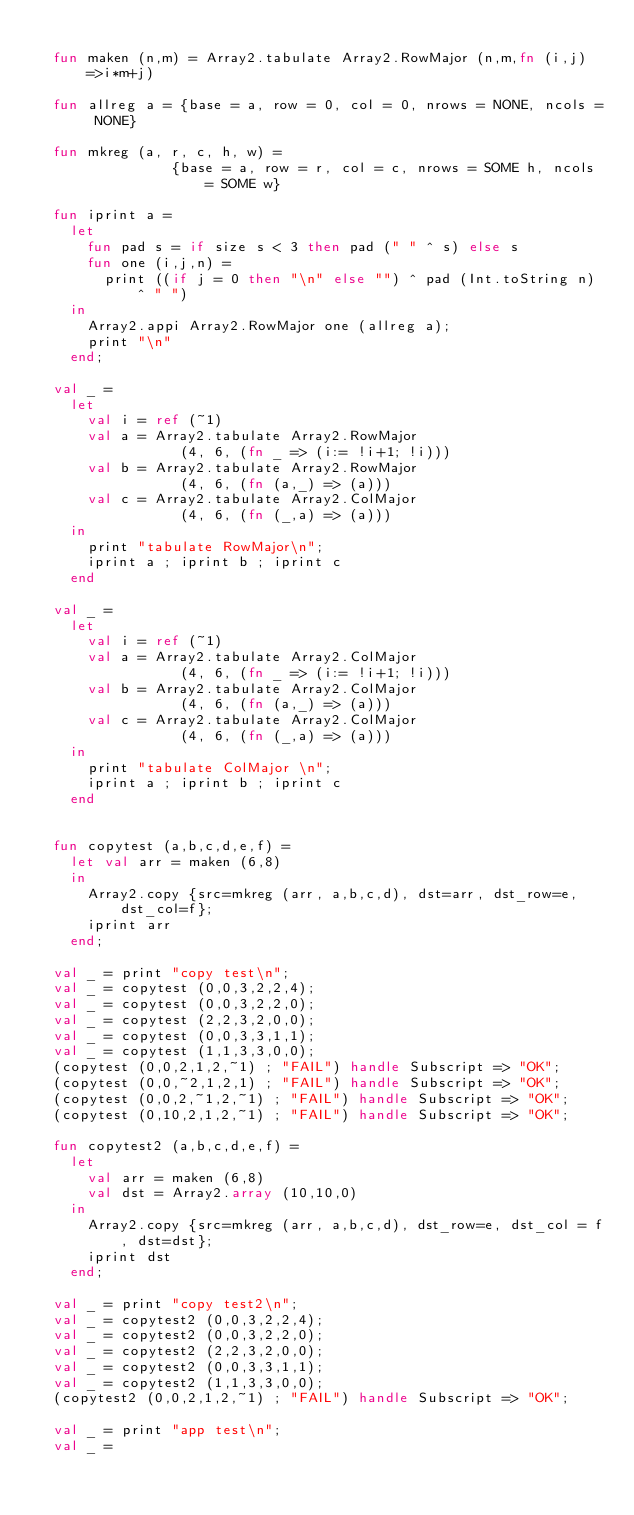<code> <loc_0><loc_0><loc_500><loc_500><_SML_>
  fun maken (n,m) = Array2.tabulate Array2.RowMajor (n,m,fn (i,j) =>i*m+j)

  fun allreg a = {base = a, row = 0, col = 0, nrows = NONE, ncols = NONE}

  fun mkreg (a, r, c, h, w) =
                {base = a, row = r, col = c, nrows = SOME h, ncols = SOME w}

  fun iprint a =
    let
      fun pad s = if size s < 3 then pad (" " ^ s) else s
      fun one (i,j,n) =
        print ((if j = 0 then "\n" else "") ^ pad (Int.toString n) ^ " ")
    in
      Array2.appi Array2.RowMajor one (allreg a);
      print "\n"
    end;

  val _ = 
    let
      val i = ref (~1)
      val a = Array2.tabulate Array2.RowMajor
                 (4, 6, (fn _ => (i:= !i+1; !i)))
      val b = Array2.tabulate Array2.RowMajor 
                 (4, 6, (fn (a,_) => (a)))
      val c = Array2.tabulate Array2.ColMajor 
                 (4, 6, (fn (_,a) => (a)))
    in
      print "tabulate RowMajor\n";
      iprint a ; iprint b ; iprint c
    end

  val _ = 
    let
      val i = ref (~1)
      val a = Array2.tabulate Array2.ColMajor 
                 (4, 6, (fn _ => (i:= !i+1; !i)))
      val b = Array2.tabulate Array2.ColMajor 
                 (4, 6, (fn (a,_) => (a)))
      val c = Array2.tabulate Array2.ColMajor 
                 (4, 6, (fn (_,a) => (a)))
    in
      print "tabulate ColMajor \n";
      iprint a ; iprint b ; iprint c
    end
  

  fun copytest (a,b,c,d,e,f) =
    let val arr = maken (6,8)
    in
      Array2.copy {src=mkreg (arr, a,b,c,d), dst=arr, dst_row=e, dst_col=f};
      iprint arr
    end;

  val _ = print "copy test\n";
  val _ = copytest (0,0,3,2,2,4);
  val _ = copytest (0,0,3,2,2,0);
  val _ = copytest (2,2,3,2,0,0);
  val _ = copytest (0,0,3,3,1,1);
  val _ = copytest (1,1,3,3,0,0);
  (copytest (0,0,2,1,2,~1) ; "FAIL") handle Subscript => "OK";
  (copytest (0,0,~2,1,2,1) ; "FAIL") handle Subscript => "OK";
  (copytest (0,0,2,~1,2,~1) ; "FAIL") handle Subscript => "OK";
  (copytest (0,10,2,1,2,~1) ; "FAIL") handle Subscript => "OK";

  fun copytest2 (a,b,c,d,e,f) =
    let 
      val arr = maken (6,8)
      val dst = Array2.array (10,10,0)
    in
      Array2.copy {src=mkreg (arr, a,b,c,d), dst_row=e, dst_col = f, dst=dst};
      iprint dst
    end;

  val _ = print "copy test2\n";
  val _ = copytest2 (0,0,3,2,2,4);
  val _ = copytest2 (0,0,3,2,2,0);
  val _ = copytest2 (2,2,3,2,0,0);
  val _ = copytest2 (0,0,3,3,1,1);
  val _ = copytest2 (1,1,3,3,0,0);
  (copytest2 (0,0,2,1,2,~1) ; "FAIL") handle Subscript => "OK";

  val _ = print "app test\n";
  val _ = </code> 